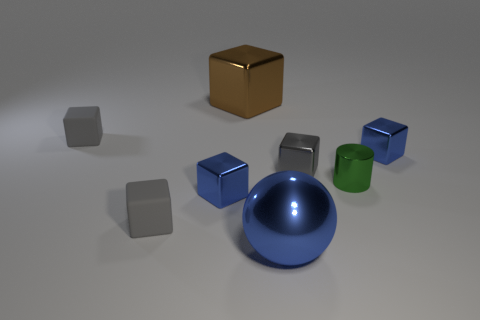Subtract all tiny gray metal cubes. How many cubes are left? 5 Add 1 blue matte blocks. How many objects exist? 9 Subtract all brown blocks. How many blocks are left? 5 Subtract all cubes. How many objects are left? 2 Add 3 tiny gray metal blocks. How many tiny gray metal blocks exist? 4 Subtract 0 gray spheres. How many objects are left? 8 Subtract 6 blocks. How many blocks are left? 0 Subtract all yellow cylinders. Subtract all gray balls. How many cylinders are left? 1 Subtract all purple spheres. How many brown cylinders are left? 0 Subtract all large blue balls. Subtract all gray metallic things. How many objects are left? 6 